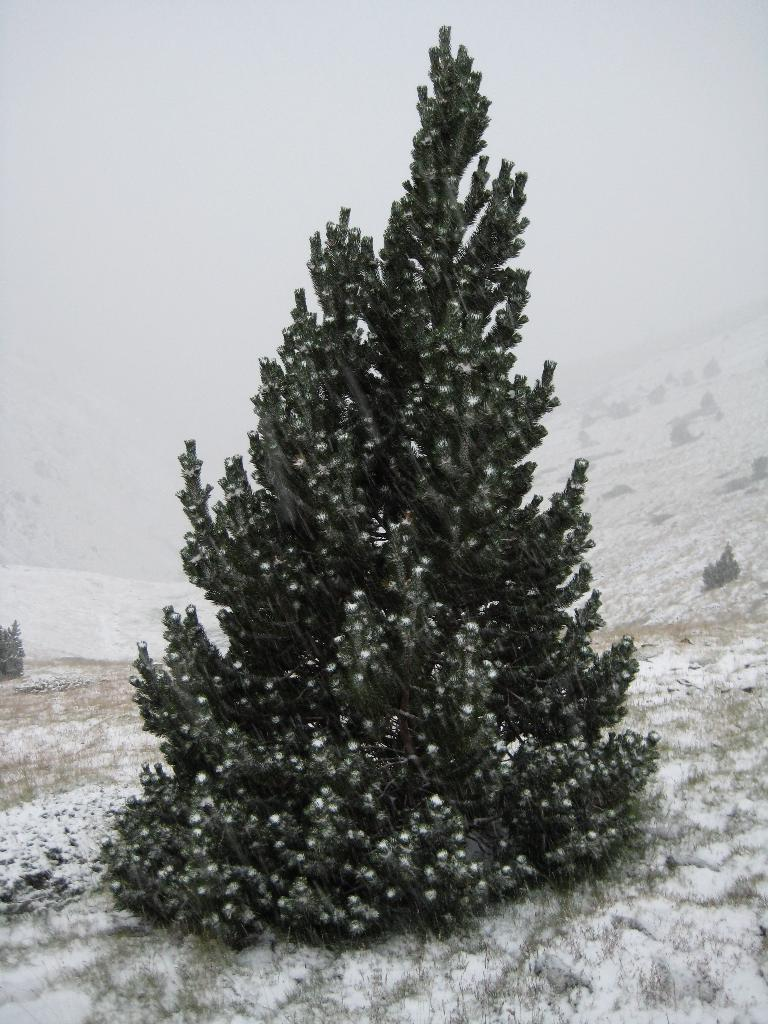What is the main subject in the middle of the picture? There is a tree present in the middle of the picture. What can be seen at the bottom of the picture? Grass and ice are visible at the bottom of the picture. How would you describe the background of the image? The background of the image is covered with fog. Is there a horse in the picture, and if so, where is it located? There is no horse present in the image. 